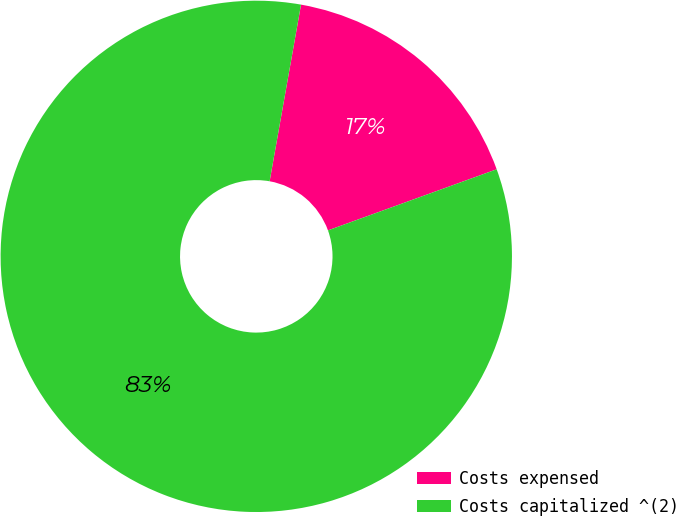<chart> <loc_0><loc_0><loc_500><loc_500><pie_chart><fcel>Costs expensed<fcel>Costs capitalized ^(2)<nl><fcel>16.67%<fcel>83.33%<nl></chart> 